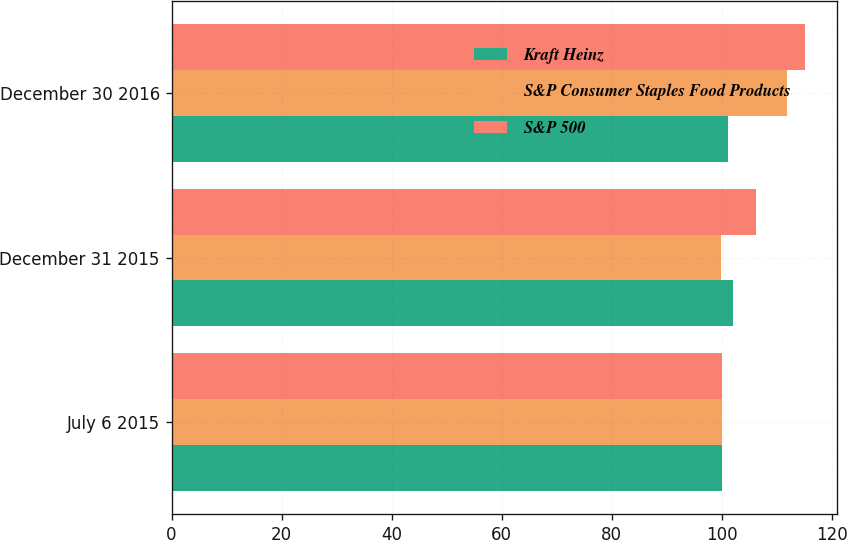<chart> <loc_0><loc_0><loc_500><loc_500><stacked_bar_chart><ecel><fcel>July 6 2015<fcel>December 31 2015<fcel>December 30 2016<nl><fcel>Kraft Heinz<fcel>100<fcel>102.07<fcel>101.035<nl><fcel>S&P Consumer Staples Food Products<fcel>100<fcel>99.85<fcel>111.79<nl><fcel>S&P 500<fcel>100<fcel>106.15<fcel>115.17<nl></chart> 